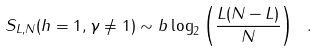<formula> <loc_0><loc_0><loc_500><loc_500>S _ { L , N } ( h = 1 , \gamma \neq 1 ) \sim b \log _ { 2 } \left ( \frac { L ( N - L ) } { N } \right ) \ .</formula> 